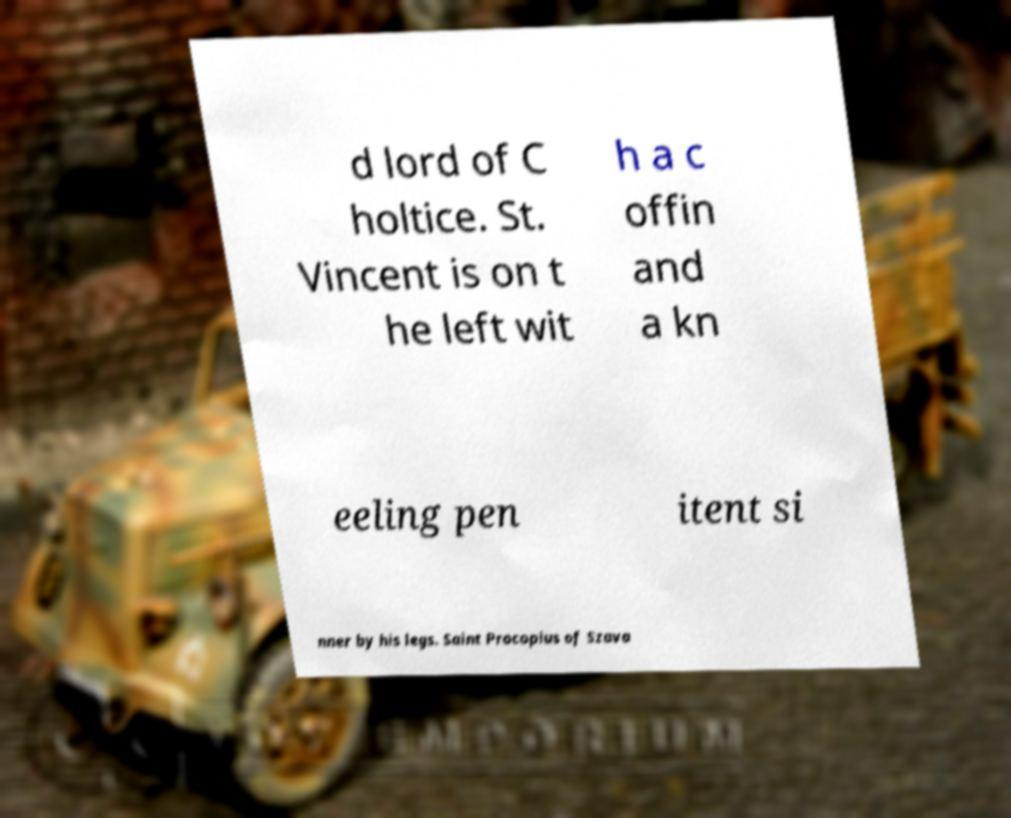What messages or text are displayed in this image? I need them in a readable, typed format. d lord of C holtice. St. Vincent is on t he left wit h a c offin and a kn eeling pen itent si nner by his legs. Saint Procopius of Szava 